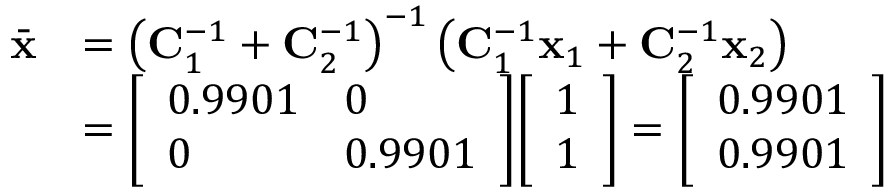<formula> <loc_0><loc_0><loc_500><loc_500>{ \begin{array} { r l } { { \bar { x } } } & { = \left ( C _ { 1 } ^ { - 1 } + C _ { 2 } ^ { - 1 } \right ) ^ { - 1 } \left ( C _ { 1 } ^ { - 1 } x _ { 1 } + C _ { 2 } ^ { - 1 } x _ { 2 } \right ) } \\ & { = { \left [ \begin{array} { l l } { 0 . 9 9 0 1 } & { 0 } \\ { 0 } & { 0 . 9 9 0 1 } \end{array} \right ] } { \left [ \begin{array} { l } { 1 } \\ { 1 } \end{array} \right ] } = { \left [ \begin{array} { l } { 0 . 9 9 0 1 } \\ { 0 . 9 9 0 1 } \end{array} \right ] } } \end{array} }</formula> 